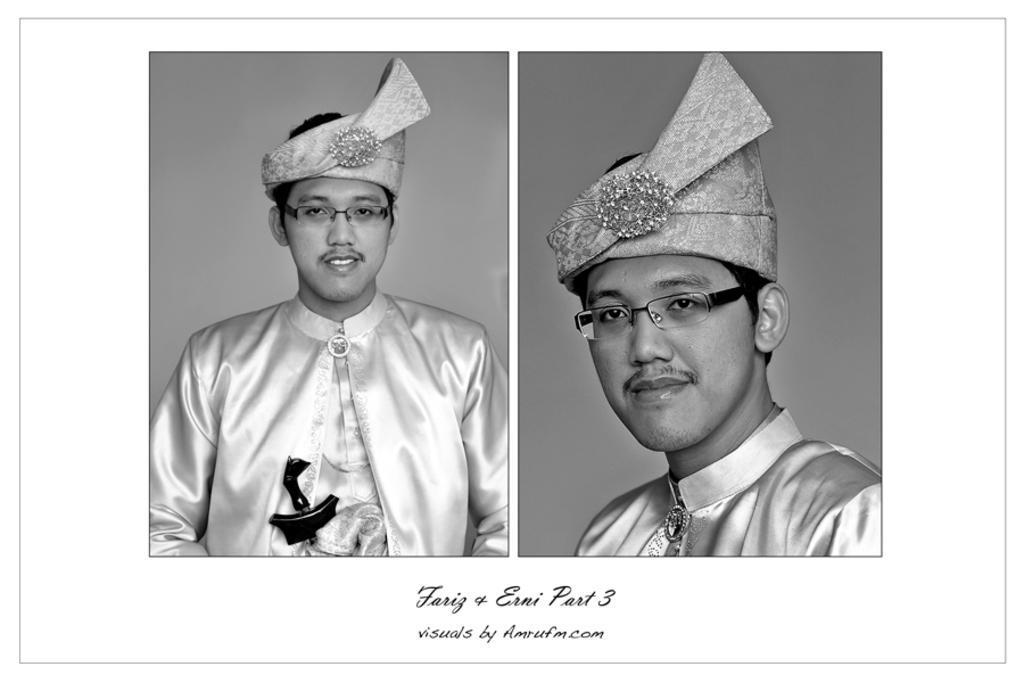In one or two sentences, can you explain what this image depicts? In the image we can see there is a collage of two pictures and the person is wearing cap. The image is in black and white colour. 